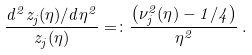Convert formula to latex. <formula><loc_0><loc_0><loc_500><loc_500>\frac { d ^ { 2 } z _ { j } ( \eta ) / d \eta ^ { 2 } } { z _ { j } ( \eta ) } = \colon \frac { \left ( \nu _ { j } ^ { 2 } ( \eta ) - 1 / 4 \right ) } { \eta ^ { 2 } } \, .</formula> 